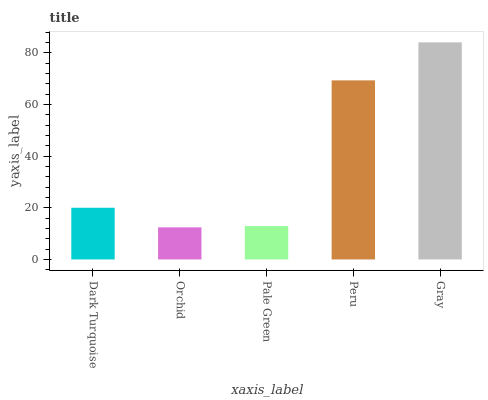Is Pale Green the minimum?
Answer yes or no. No. Is Pale Green the maximum?
Answer yes or no. No. Is Pale Green greater than Orchid?
Answer yes or no. Yes. Is Orchid less than Pale Green?
Answer yes or no. Yes. Is Orchid greater than Pale Green?
Answer yes or no. No. Is Pale Green less than Orchid?
Answer yes or no. No. Is Dark Turquoise the high median?
Answer yes or no. Yes. Is Dark Turquoise the low median?
Answer yes or no. Yes. Is Peru the high median?
Answer yes or no. No. Is Peru the low median?
Answer yes or no. No. 